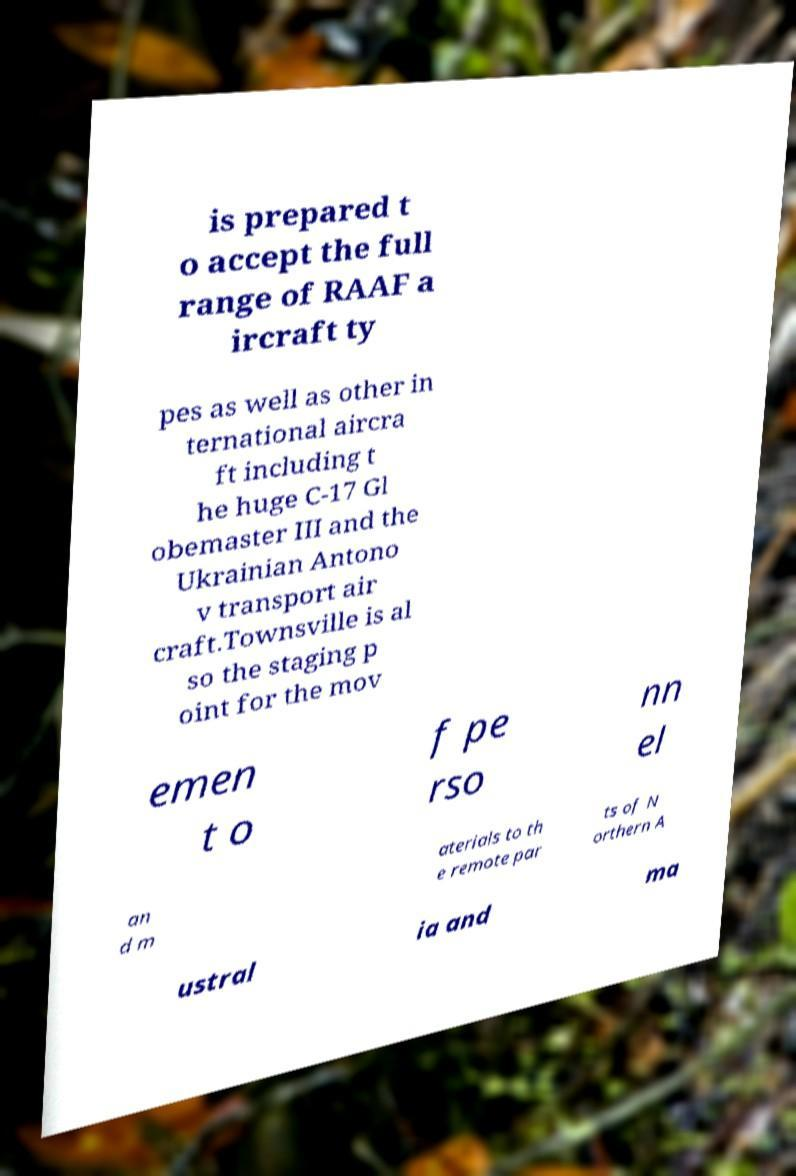For documentation purposes, I need the text within this image transcribed. Could you provide that? is prepared t o accept the full range of RAAF a ircraft ty pes as well as other in ternational aircra ft including t he huge C-17 Gl obemaster III and the Ukrainian Antono v transport air craft.Townsville is al so the staging p oint for the mov emen t o f pe rso nn el an d m aterials to th e remote par ts of N orthern A ustral ia and ma 